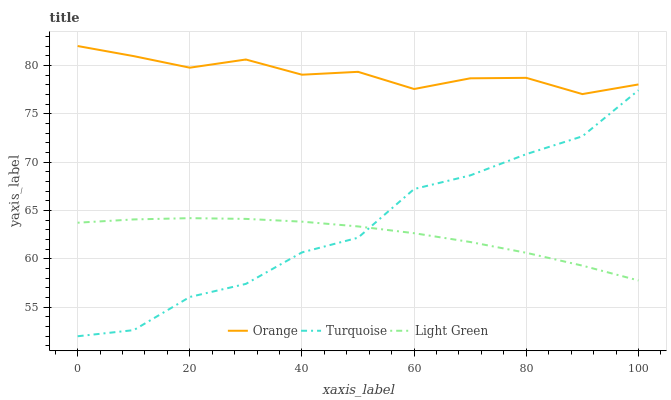Does Turquoise have the minimum area under the curve?
Answer yes or no. No. Does Turquoise have the maximum area under the curve?
Answer yes or no. No. Is Turquoise the smoothest?
Answer yes or no. No. Is Light Green the roughest?
Answer yes or no. No. Does Light Green have the lowest value?
Answer yes or no. No. Does Turquoise have the highest value?
Answer yes or no. No. Is Light Green less than Orange?
Answer yes or no. Yes. Is Orange greater than Light Green?
Answer yes or no. Yes. Does Light Green intersect Orange?
Answer yes or no. No. 